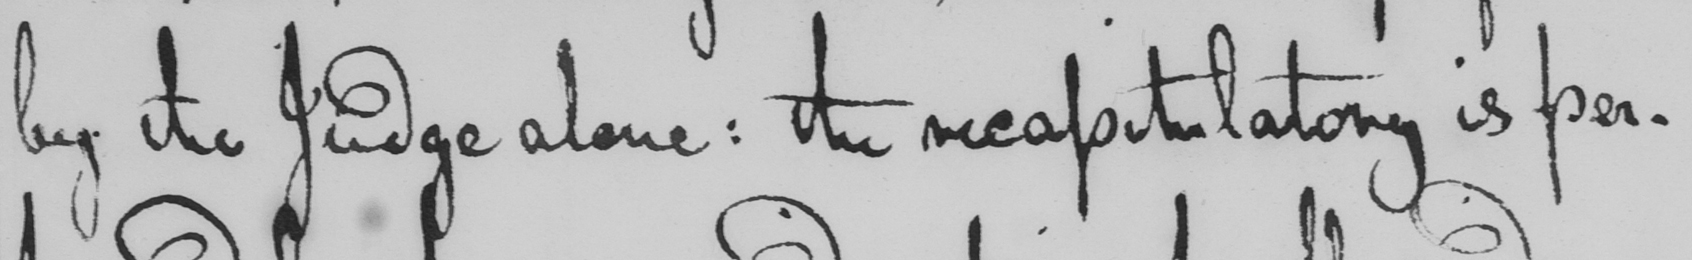Please provide the text content of this handwritten line. by the Judge alone :  the recapitulatory is per- 